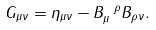Convert formula to latex. <formula><loc_0><loc_0><loc_500><loc_500>G _ { \mu \nu } = \eta _ { \mu \nu } - B _ { \mu } ^ { \ \rho } B _ { \rho \nu } .</formula> 